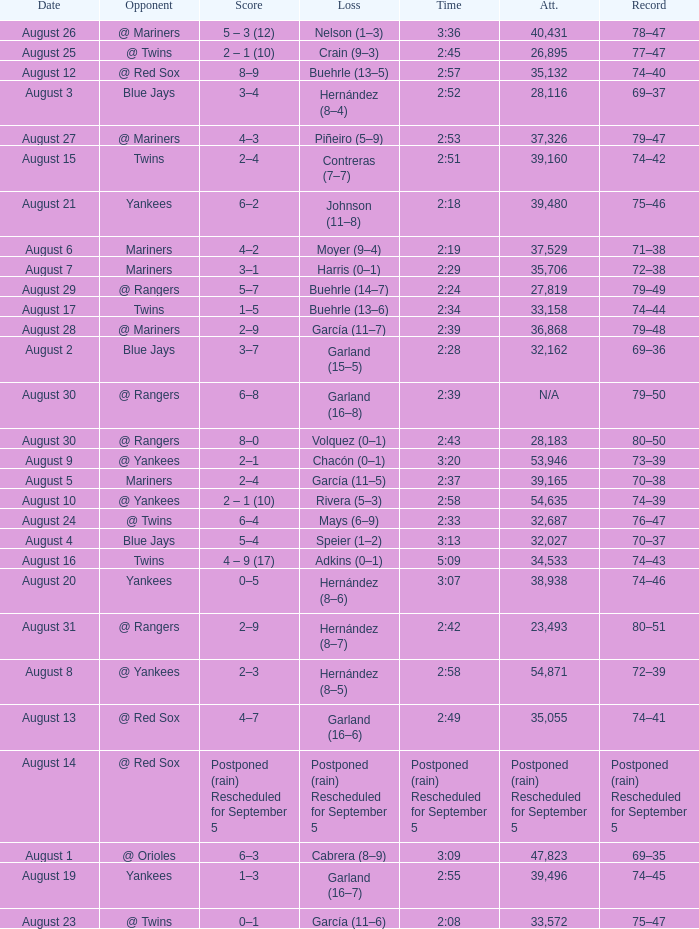Who lost on August 27? Piñeiro (5–9). Can you give me this table as a dict? {'header': ['Date', 'Opponent', 'Score', 'Loss', 'Time', 'Att.', 'Record'], 'rows': [['August 26', '@ Mariners', '5 – 3 (12)', 'Nelson (1–3)', '3:36', '40,431', '78–47'], ['August 25', '@ Twins', '2 – 1 (10)', 'Crain (9–3)', '2:45', '26,895', '77–47'], ['August 12', '@ Red Sox', '8–9', 'Buehrle (13–5)', '2:57', '35,132', '74–40'], ['August 3', 'Blue Jays', '3–4', 'Hernández (8–4)', '2:52', '28,116', '69–37'], ['August 27', '@ Mariners', '4–3', 'Piñeiro (5–9)', '2:53', '37,326', '79–47'], ['August 15', 'Twins', '2–4', 'Contreras (7–7)', '2:51', '39,160', '74–42'], ['August 21', 'Yankees', '6–2', 'Johnson (11–8)', '2:18', '39,480', '75–46'], ['August 6', 'Mariners', '4–2', 'Moyer (9–4)', '2:19', '37,529', '71–38'], ['August 7', 'Mariners', '3–1', 'Harris (0–1)', '2:29', '35,706', '72–38'], ['August 29', '@ Rangers', '5–7', 'Buehrle (14–7)', '2:24', '27,819', '79–49'], ['August 17', 'Twins', '1–5', 'Buehrle (13–6)', '2:34', '33,158', '74–44'], ['August 28', '@ Mariners', '2–9', 'García (11–7)', '2:39', '36,868', '79–48'], ['August 2', 'Blue Jays', '3–7', 'Garland (15–5)', '2:28', '32,162', '69–36'], ['August 30', '@ Rangers', '6–8', 'Garland (16–8)', '2:39', 'N/A', '79–50'], ['August 30', '@ Rangers', '8–0', 'Volquez (0–1)', '2:43', '28,183', '80–50'], ['August 9', '@ Yankees', '2–1', 'Chacón (0–1)', '3:20', '53,946', '73–39'], ['August 5', 'Mariners', '2–4', 'García (11–5)', '2:37', '39,165', '70–38'], ['August 10', '@ Yankees', '2 – 1 (10)', 'Rivera (5–3)', '2:58', '54,635', '74–39'], ['August 24', '@ Twins', '6–4', 'Mays (6–9)', '2:33', '32,687', '76–47'], ['August 4', 'Blue Jays', '5–4', 'Speier (1–2)', '3:13', '32,027', '70–37'], ['August 16', 'Twins', '4 – 9 (17)', 'Adkins (0–1)', '5:09', '34,533', '74–43'], ['August 20', 'Yankees', '0–5', 'Hernández (8–6)', '3:07', '38,938', '74–46'], ['August 31', '@ Rangers', '2–9', 'Hernández (8–7)', '2:42', '23,493', '80–51'], ['August 8', '@ Yankees', '2–3', 'Hernández (8–5)', '2:58', '54,871', '72–39'], ['August 13', '@ Red Sox', '4–7', 'Garland (16–6)', '2:49', '35,055', '74–41'], ['August 14', '@ Red Sox', 'Postponed (rain) Rescheduled for September 5', 'Postponed (rain) Rescheduled for September 5', 'Postponed (rain) Rescheduled for September 5', 'Postponed (rain) Rescheduled for September 5', 'Postponed (rain) Rescheduled for September 5'], ['August 1', '@ Orioles', '6–3', 'Cabrera (8–9)', '3:09', '47,823', '69–35'], ['August 19', 'Yankees', '1–3', 'Garland (16–7)', '2:55', '39,496', '74–45'], ['August 23', '@ Twins', '0–1', 'García (11–6)', '2:08', '33,572', '75–47']]} 